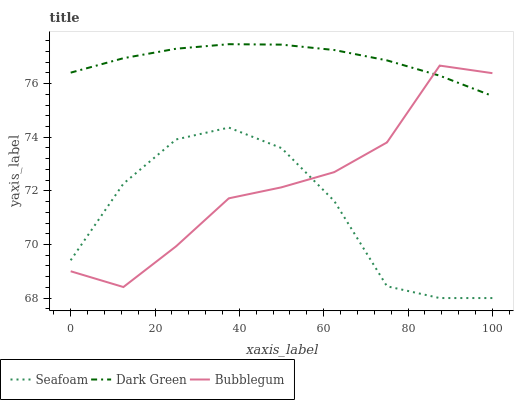Does Bubblegum have the minimum area under the curve?
Answer yes or no. No. Does Bubblegum have the maximum area under the curve?
Answer yes or no. No. Is Bubblegum the smoothest?
Answer yes or no. No. Is Dark Green the roughest?
Answer yes or no. No. Does Bubblegum have the lowest value?
Answer yes or no. No. Does Bubblegum have the highest value?
Answer yes or no. No. Is Seafoam less than Dark Green?
Answer yes or no. Yes. Is Dark Green greater than Seafoam?
Answer yes or no. Yes. Does Seafoam intersect Dark Green?
Answer yes or no. No. 